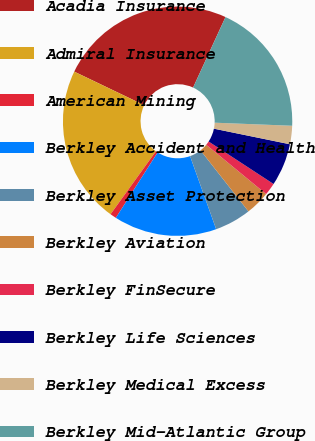Convert chart to OTSL. <chart><loc_0><loc_0><loc_500><loc_500><pie_chart><fcel>Acadia Insurance<fcel>Admiral Insurance<fcel>American Mining<fcel>Berkley Accident and Health<fcel>Berkley Asset Protection<fcel>Berkley Aviation<fcel>Berkley FinSecure<fcel>Berkley Life Sciences<fcel>Berkley Medical Excess<fcel>Berkley Mid-Atlantic Group<nl><fcel>24.74%<fcel>22.18%<fcel>0.89%<fcel>14.51%<fcel>5.14%<fcel>3.44%<fcel>1.74%<fcel>6.0%<fcel>2.59%<fcel>18.77%<nl></chart> 